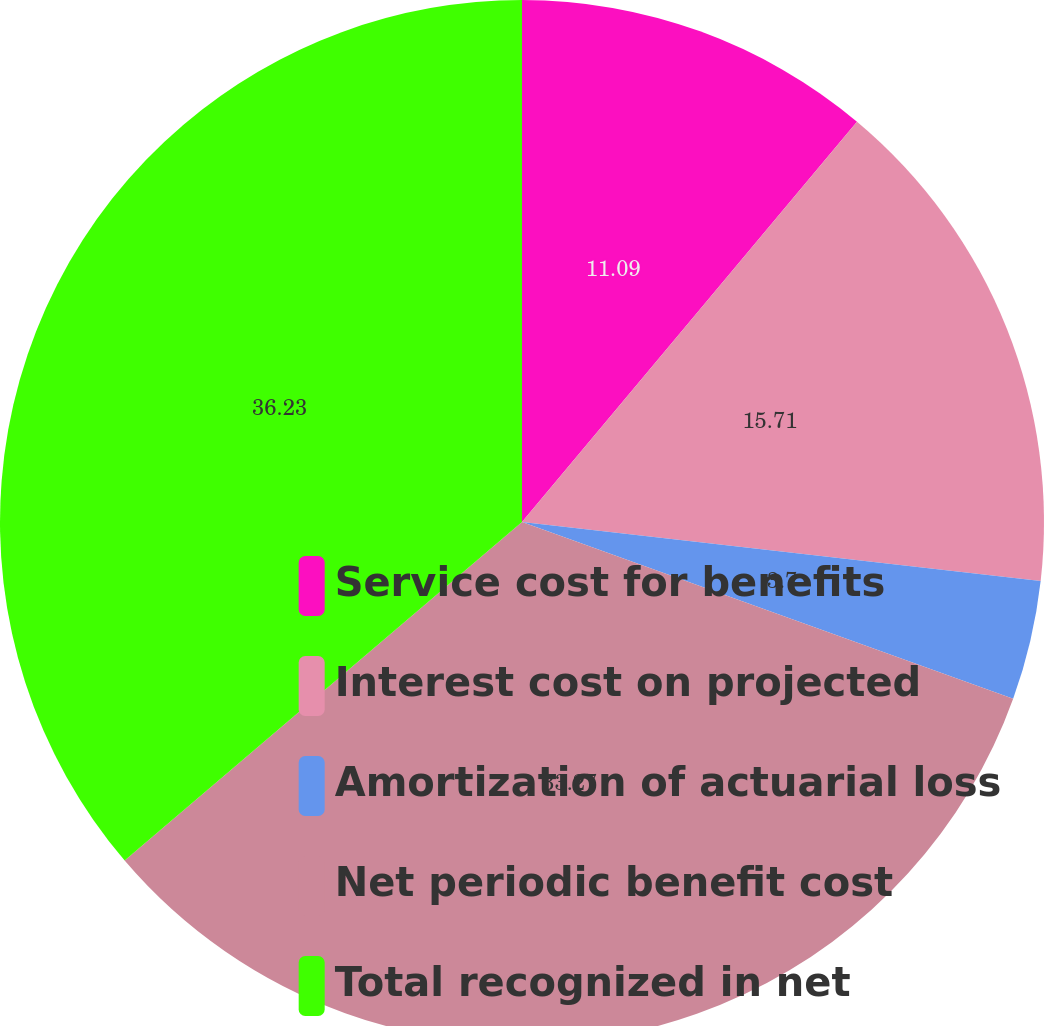Convert chart to OTSL. <chart><loc_0><loc_0><loc_500><loc_500><pie_chart><fcel>Service cost for benefits<fcel>Interest cost on projected<fcel>Amortization of actuarial loss<fcel>Net periodic benefit cost<fcel>Total recognized in net<nl><fcel>11.09%<fcel>15.71%<fcel>3.7%<fcel>33.27%<fcel>36.23%<nl></chart> 